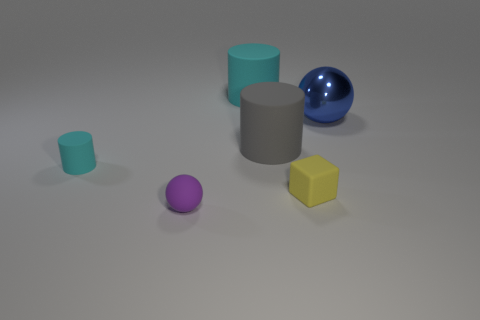What is the color of the other object that is the same shape as the big blue metallic object?
Provide a short and direct response. Purple. Do the metal object and the gray cylinder have the same size?
Offer a very short reply. Yes. Are there an equal number of large rubber objects that are to the right of the yellow matte block and red matte spheres?
Make the answer very short. Yes. There is a sphere that is right of the small yellow thing; is there a tiny rubber ball right of it?
Ensure brevity in your answer.  No. What size is the cylinder that is to the right of the cyan rubber cylinder that is to the right of the small rubber object that is behind the small yellow rubber thing?
Make the answer very short. Large. What is the cylinder that is to the left of the sphere that is in front of the yellow object made of?
Make the answer very short. Rubber. Are there any other large matte objects of the same shape as the yellow object?
Keep it short and to the point. No. What is the shape of the big gray rubber object?
Ensure brevity in your answer.  Cylinder. What material is the big cylinder that is in front of the cyan matte cylinder that is behind the cyan matte cylinder that is in front of the large blue sphere?
Provide a succinct answer. Rubber. Are there more cyan cylinders that are to the right of the large ball than small cyan matte cylinders?
Ensure brevity in your answer.  No. 